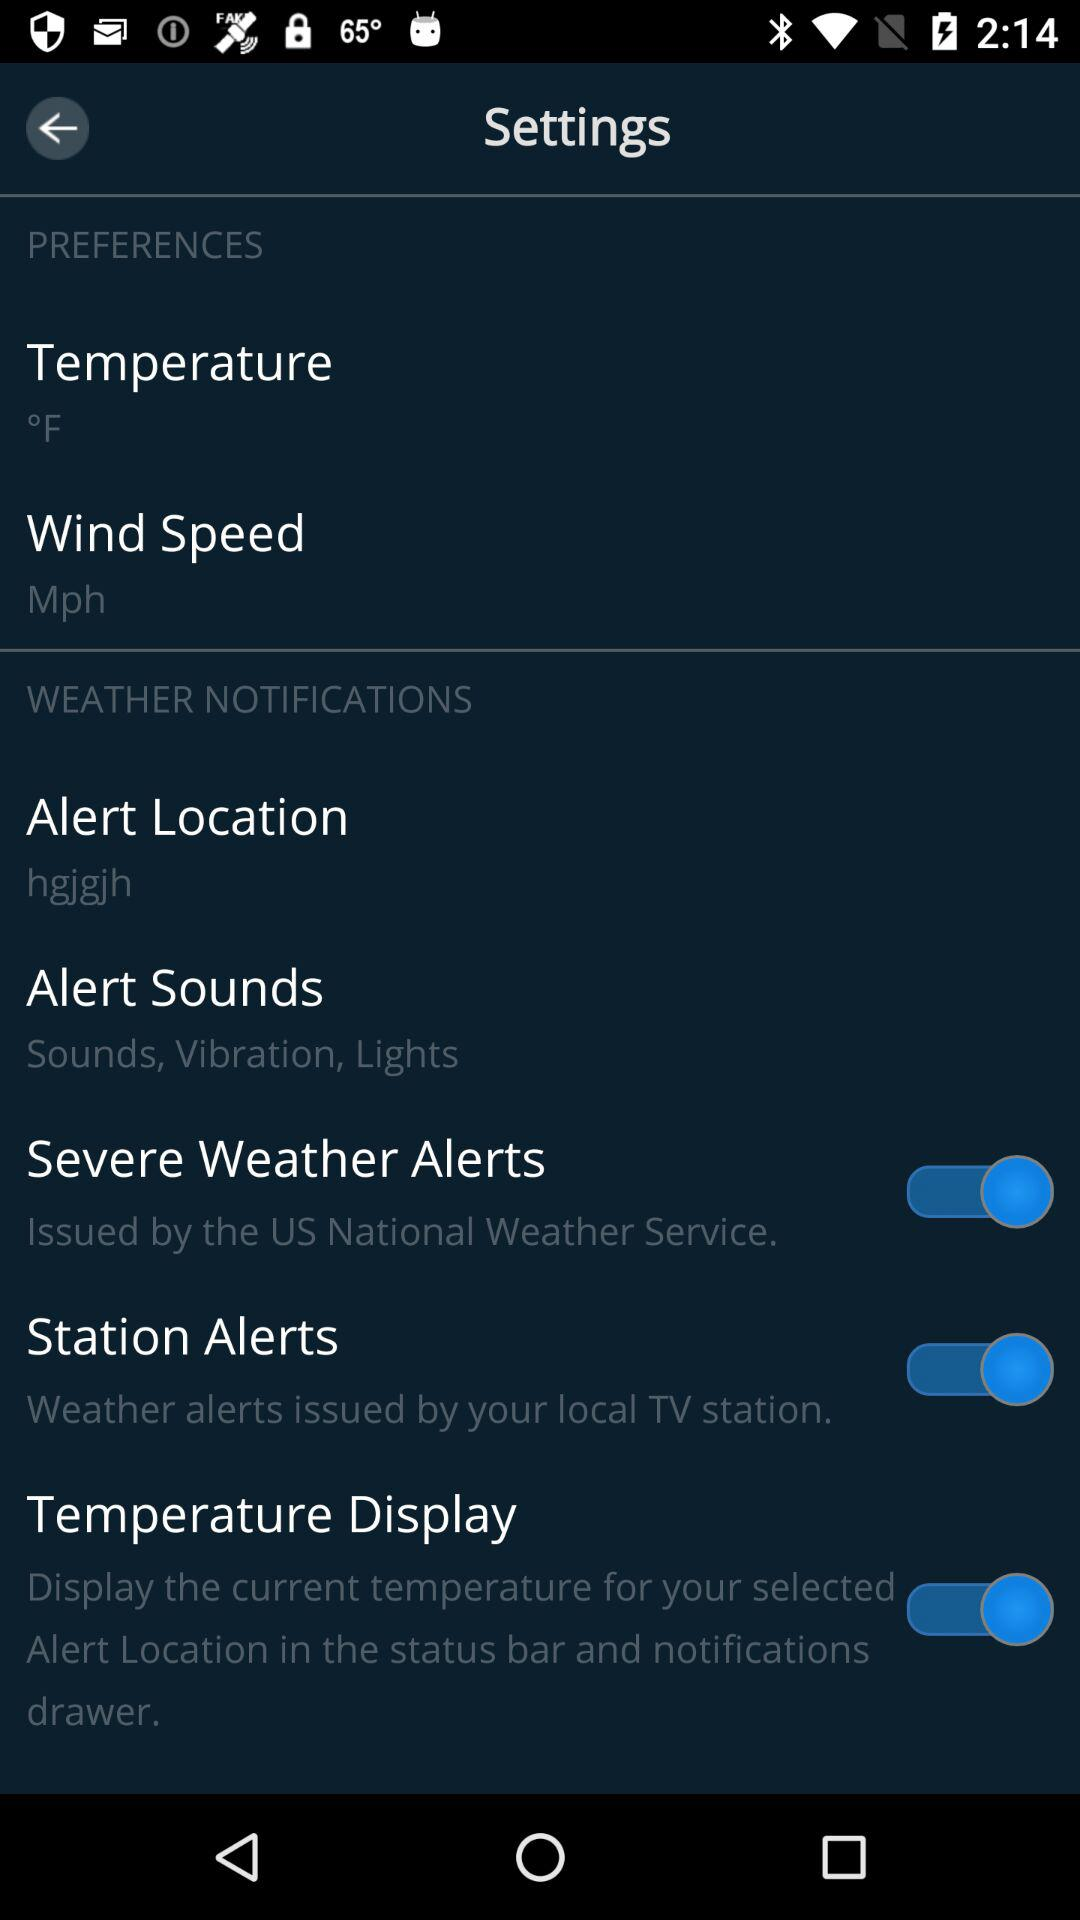What is the status of "Station Alerts"? The status is "on". 